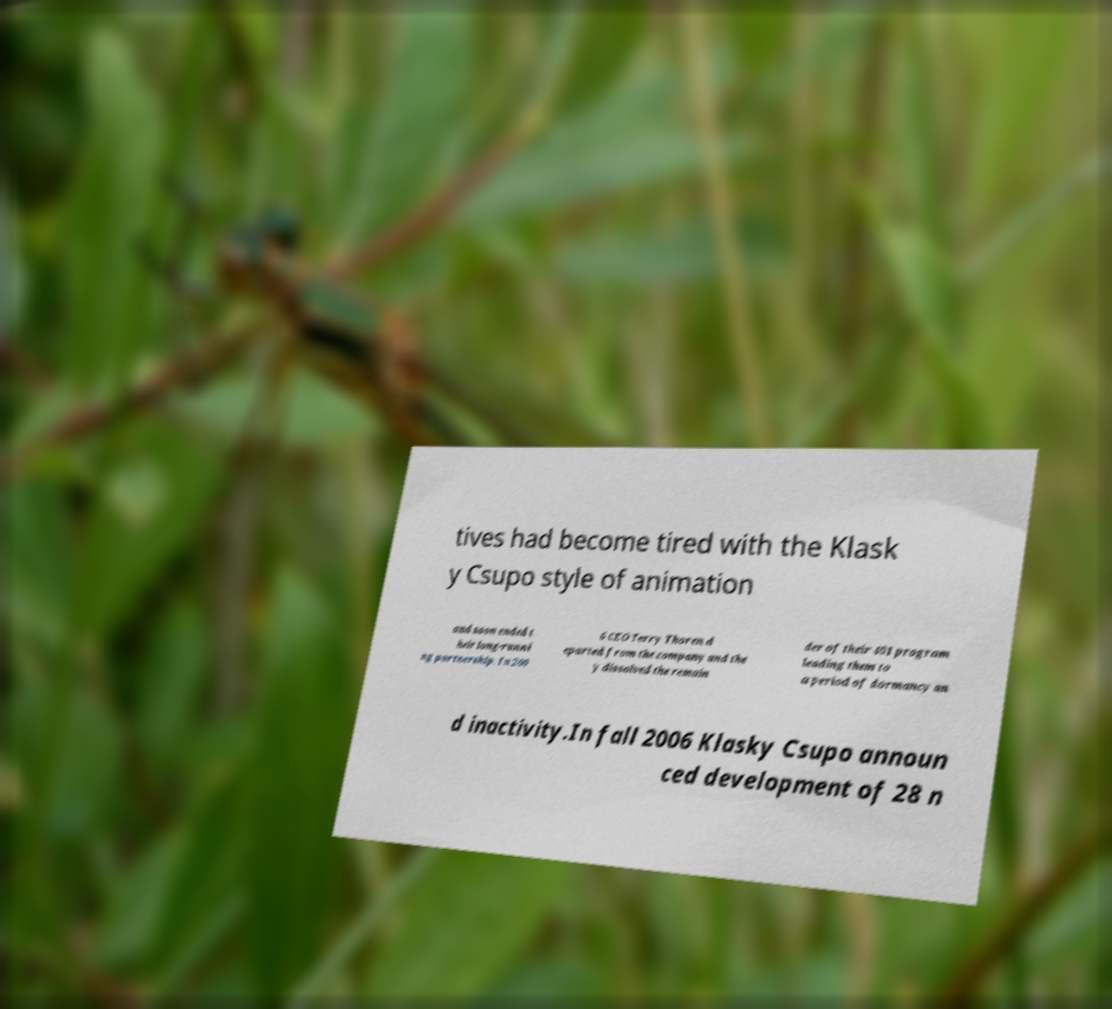Could you assist in decoding the text presented in this image and type it out clearly? tives had become tired with the Klask y Csupo style of animation and soon ended t heir long-runni ng partnership. In 200 6 CEO Terry Thoren d eparted from the company and the y dissolved the remain der of their 401 program leading them to a period of dormancy an d inactivity.In fall 2006 Klasky Csupo announ ced development of 28 n 